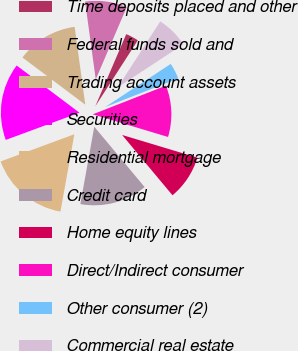<chart> <loc_0><loc_0><loc_500><loc_500><pie_chart><fcel>Time deposits placed and other<fcel>Federal funds sold and<fcel>Trading account assets<fcel>Securities<fcel>Residential mortgage<fcel>Credit card<fcel>Home equity lines<fcel>Direct/Indirect consumer<fcel>Other consumer (2)<fcel>Commercial real estate<nl><fcel>2.66%<fcel>8.61%<fcel>12.58%<fcel>15.88%<fcel>16.54%<fcel>13.9%<fcel>9.27%<fcel>10.59%<fcel>3.32%<fcel>6.63%<nl></chart> 